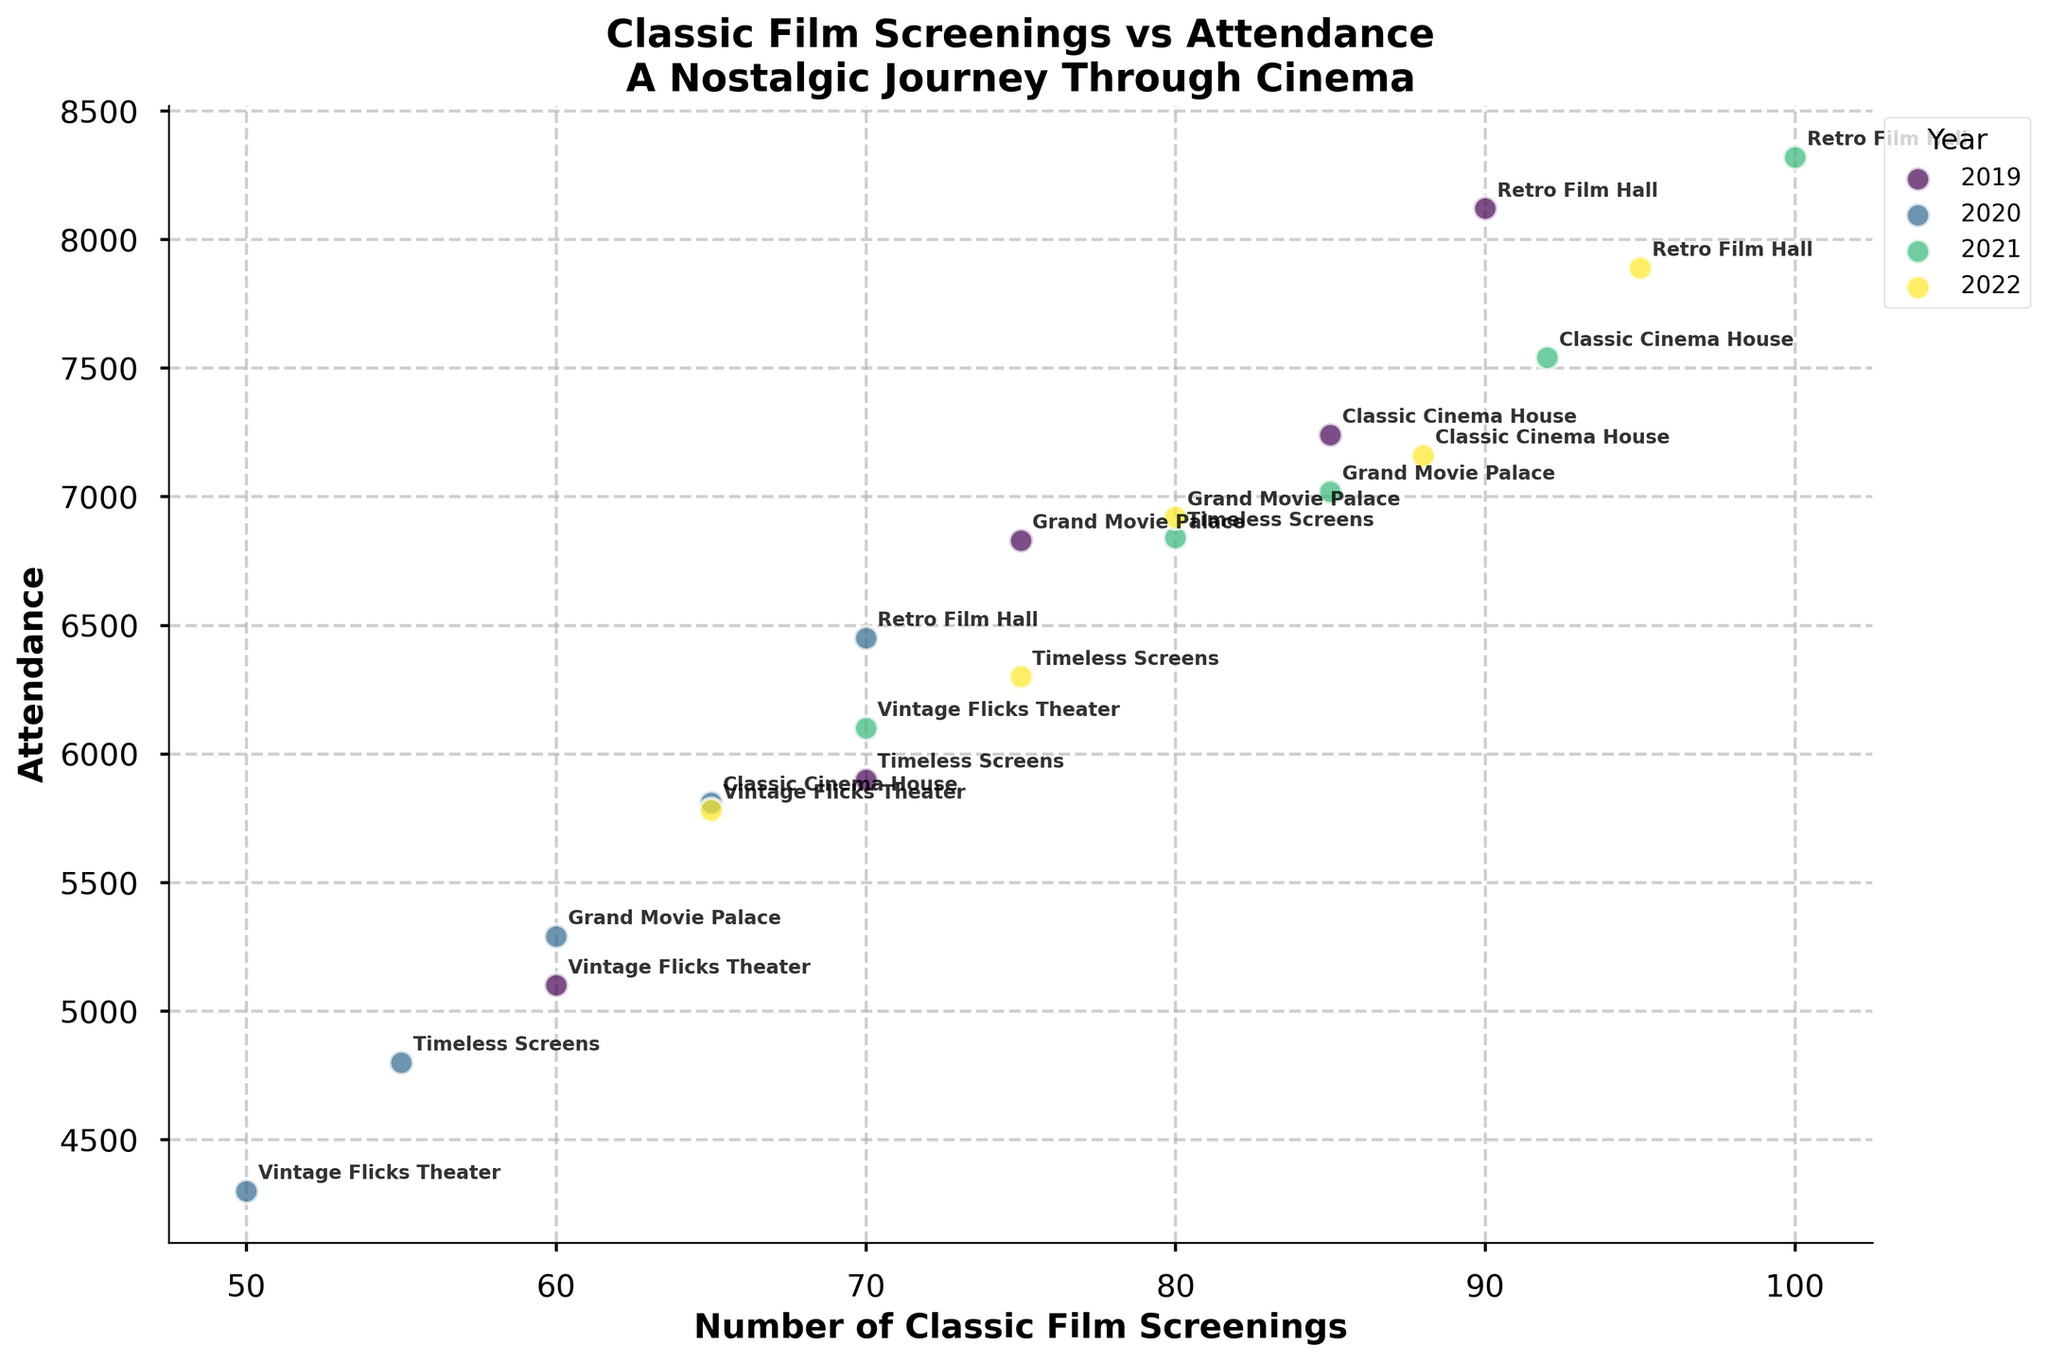What is the title of the plot? The title can be found at the top of the plot. It is "Classic Film Screenings vs Attendance: A Nostalgic Journey Through Cinema"
Answer: Classic Film Screenings vs Attendance: A Nostalgic Journey Through Cinema How many data points are there for the year 2021? Each data point represents a theater's screenings and attendance for a year. In 2021, five theaters are listed, so there are five data points.
Answer: 5 Which theater has the highest attendance in 2022? Locate the 2022 data points and find the one with the highest y-value (attendance). Retro Film Hall has the highest attendance at 7890.
Answer: Retro Film Hall What is the color scheme used for the years? The plot uses a gradient color scheme. For 2019, it's the darkest color; for 2022, it's the lightest. Intermediate years have colors in between.
Answer: Viridis What was the average number of screenings for 2020? Identify the screenings for 2020. Sum: (65+60+70+50+55) = 300. Average: 300/5 = 60
Answer: 60 Which year shows the highest overall attendance across theaters? Sum the attendance for each year and compare. 2019 has the highest total (32490).
Answer: 2019 What is the difference in attendance between Grand Movie Palace and Timeless Screens in 2021? Attendance for Grand Movie Palace in 2021 is 7020, and for Timeless Screens it is 6840. Difference: 7020 - 6840 = 180
Answer: 180 Which theater had the lowest number of screenings in any year? Check the x-values across all years. Vintage Flicks Theater had the lowest screenings of 50 in 2020.
Answer: Vintage Flicks Theater Is there any correlation between the number of screenings and attendance? Look for the pattern in the scatter plot. A positive correlation is present as data points generally trend upward from left to right.
Answer: Yes, positive correlation Are there any outliers in the data for 2019? Examine the 2019 data points. One can notice that Vintage Flicks Theater has notably lower values compared to others.
Answer: Vintage Flicks Theater 